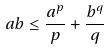<formula> <loc_0><loc_0><loc_500><loc_500>a b \leq \frac { a ^ { p } } { p } + \frac { b ^ { q } } { q }</formula> 